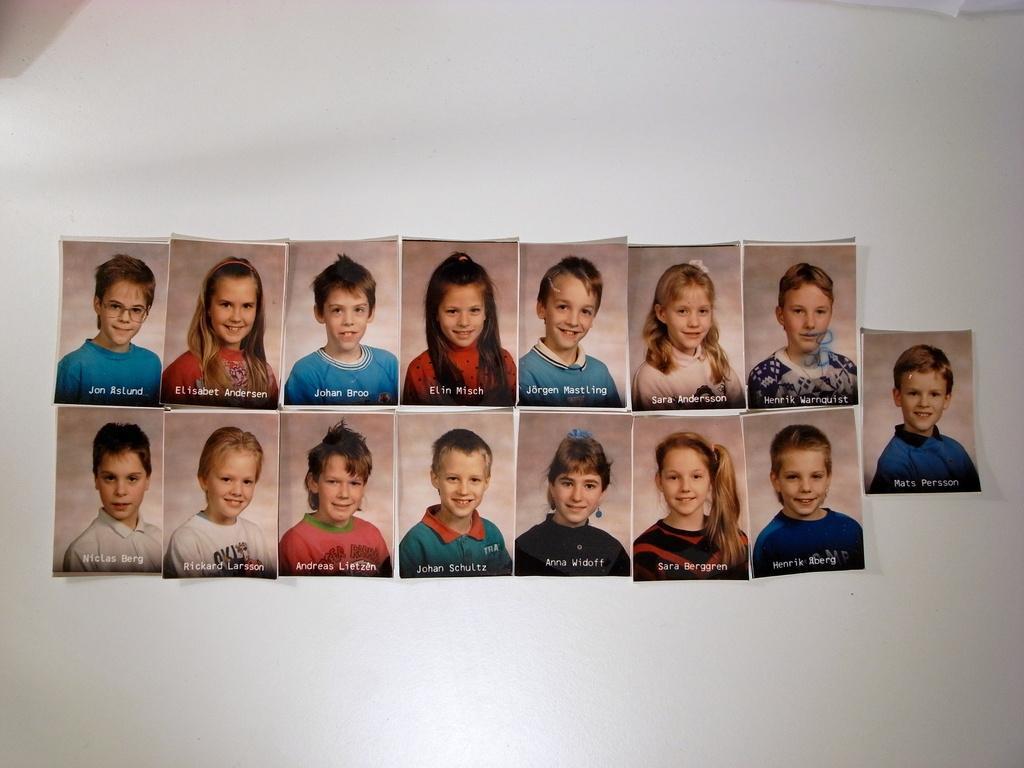Can you describe this image briefly? In this image I can see photographs of some kids sticking on to the wall, each photograph is having some text at the bottom. 